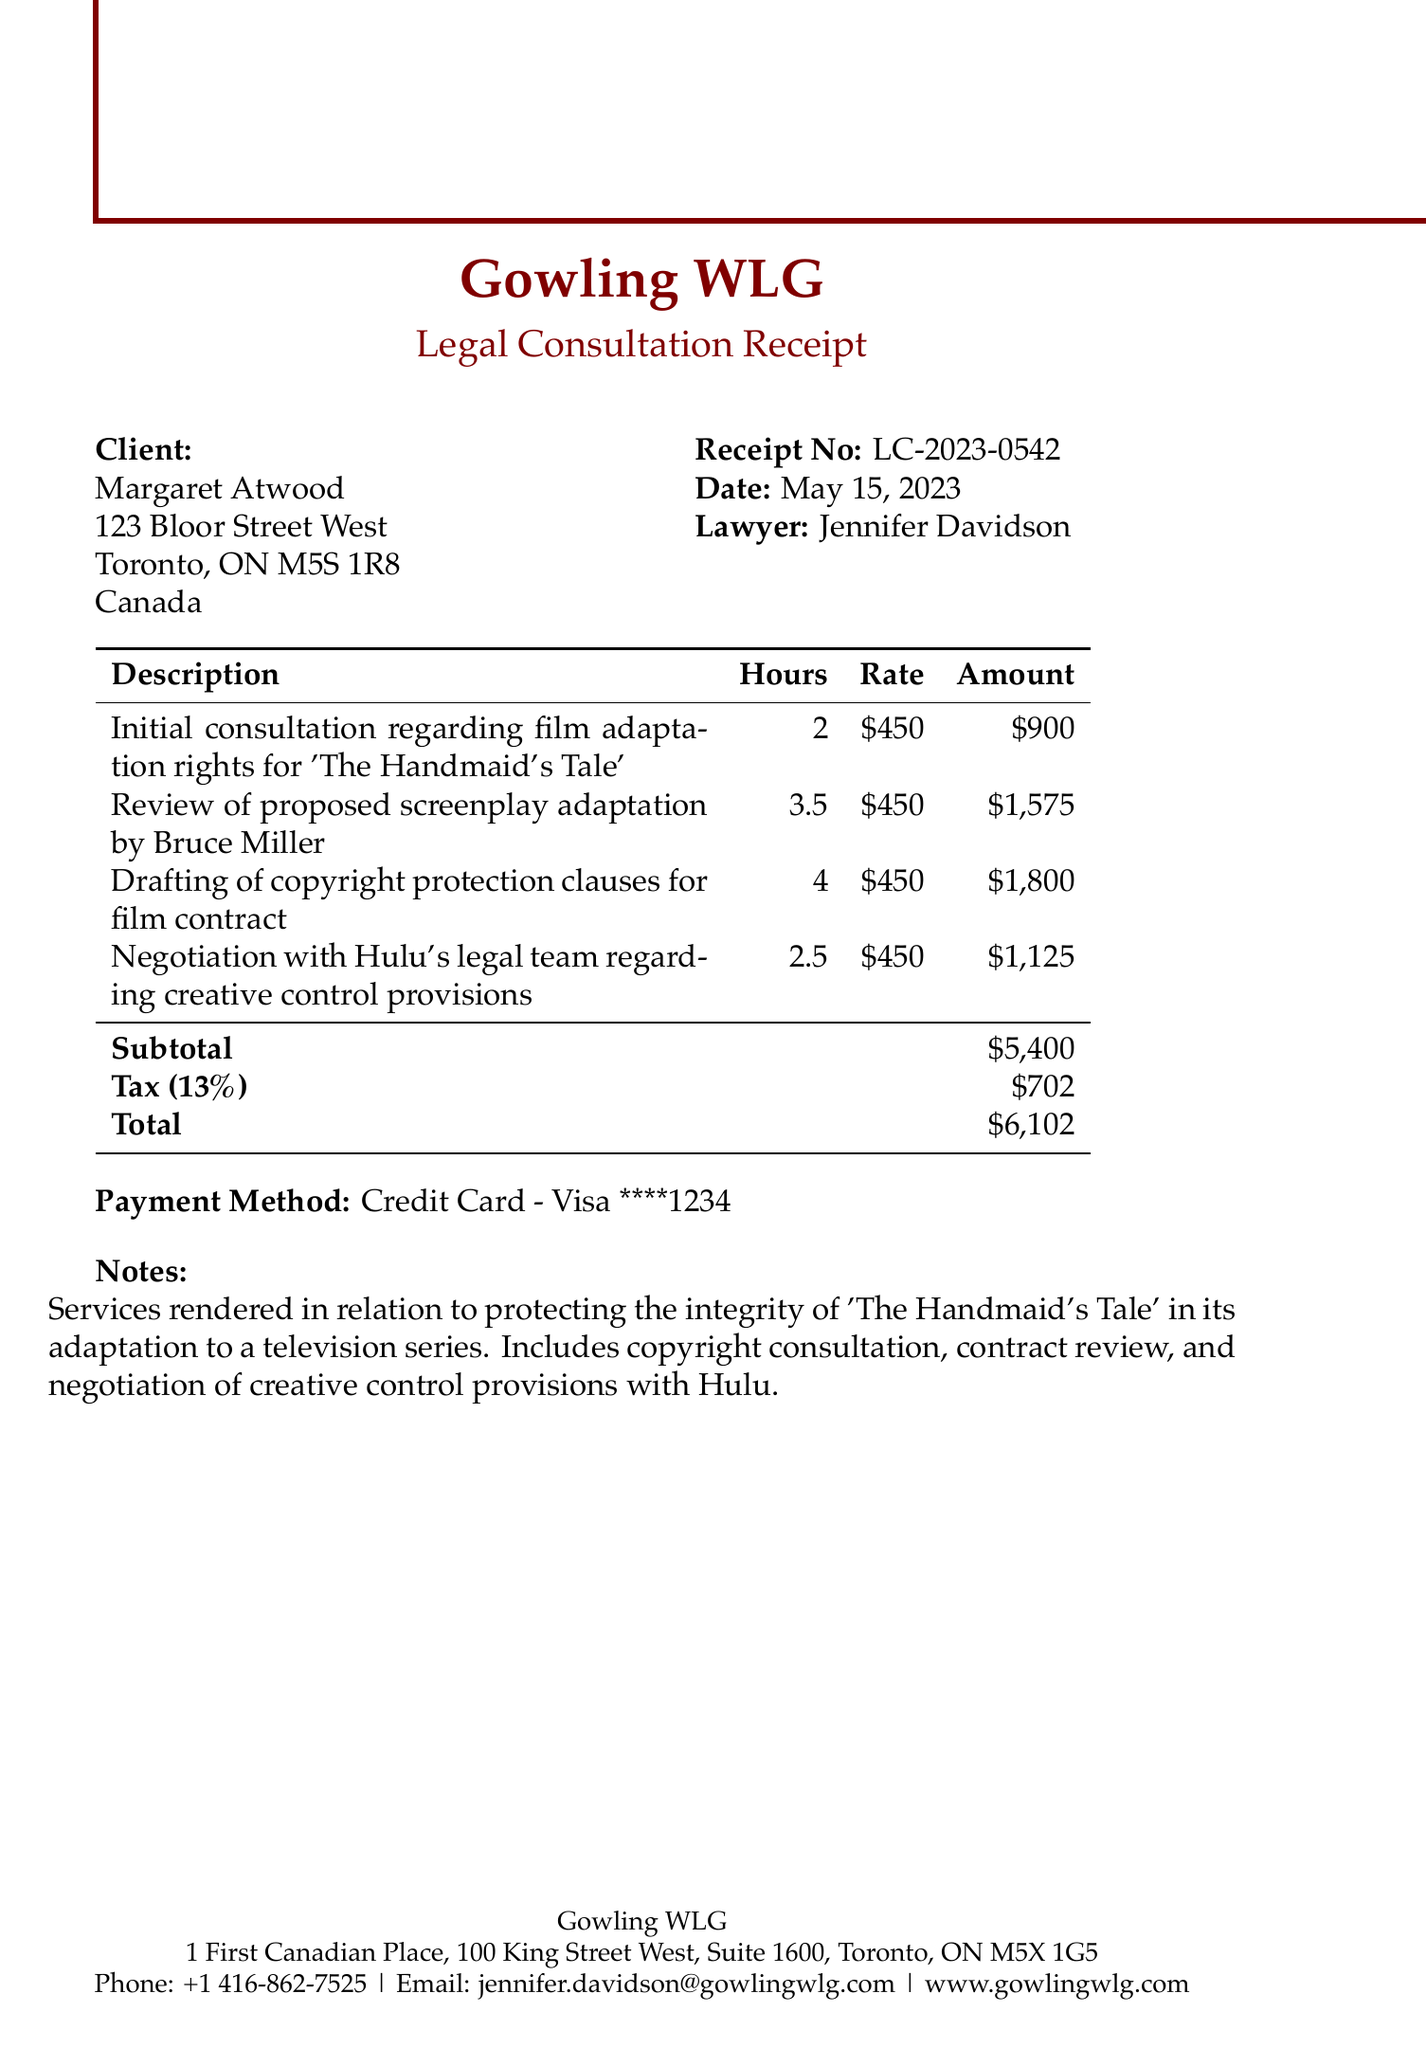What is the receipt number? The receipt number is specified at the top of the document.
Answer: LC-2023-0542 Who is the client? The client's name is listed in the document.
Answer: Margaret Atwood What is the total amount due? The total amount is calculated at the end of the receipt.
Answer: $6102 How many hours were spent on drafting copyright protection clauses? The number of hours for that service is provided in the table of services.
Answer: 4 What is the tax rate applied? The tax rate is mentioned in the context of the subtotal and total amount.
Answer: 13% What service involved negotiation with Hulu's legal team? The document outlines various services rendered, including one related to Hulu.
Answer: Negotiation with Hulu's legal team regarding creative control provisions What is the lawyer's name? The lawyer's name is mentioned in the receipt details.
Answer: Jennifer Davidson What payment method was used? The payment method is listed toward the end of the document.
Answer: Credit Card - Visa ****1234 